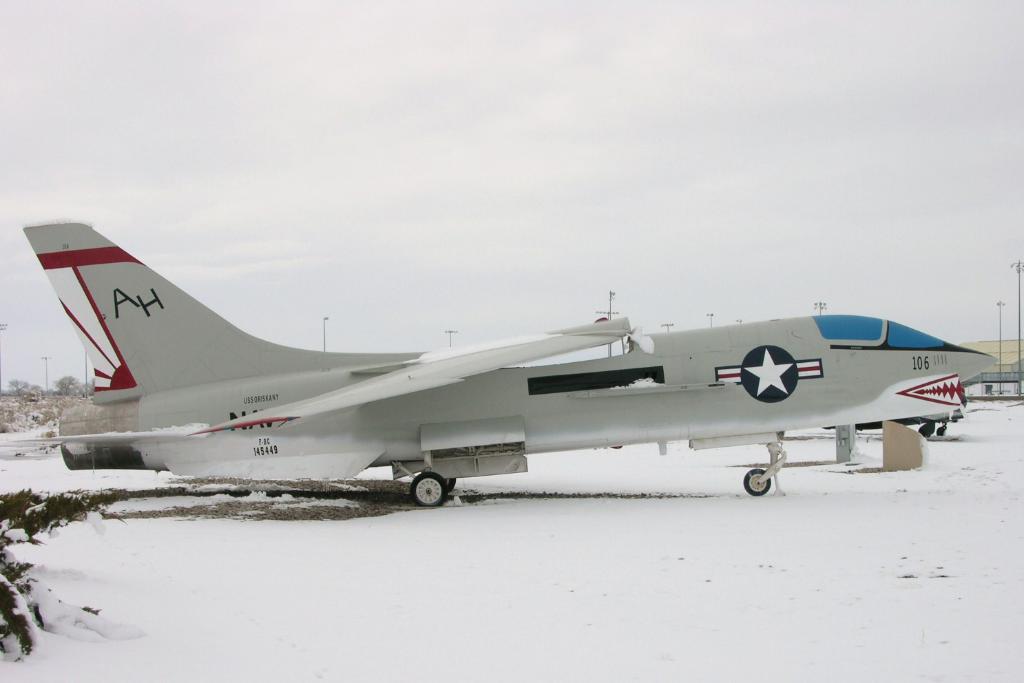Two letters on the tail?
Give a very brief answer. Ah. What is the number found on the head of the plane?
Your answer should be very brief. 106. 